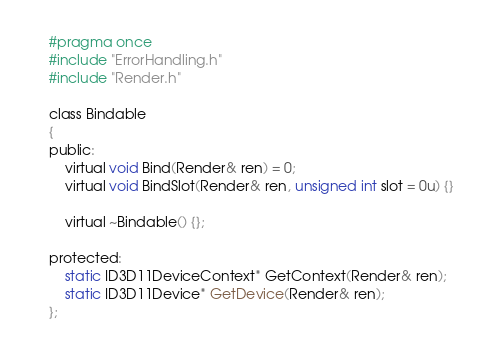Convert code to text. <code><loc_0><loc_0><loc_500><loc_500><_C_>#pragma once
#include "ErrorHandling.h"
#include "Render.h"

class Bindable
{
public:
	virtual void Bind(Render& ren) = 0;
	virtual void BindSlot(Render& ren, unsigned int slot = 0u) {}

	virtual ~Bindable() {};

protected:
	static ID3D11DeviceContext* GetContext(Render& ren);
	static ID3D11Device* GetDevice(Render& ren);
};</code> 